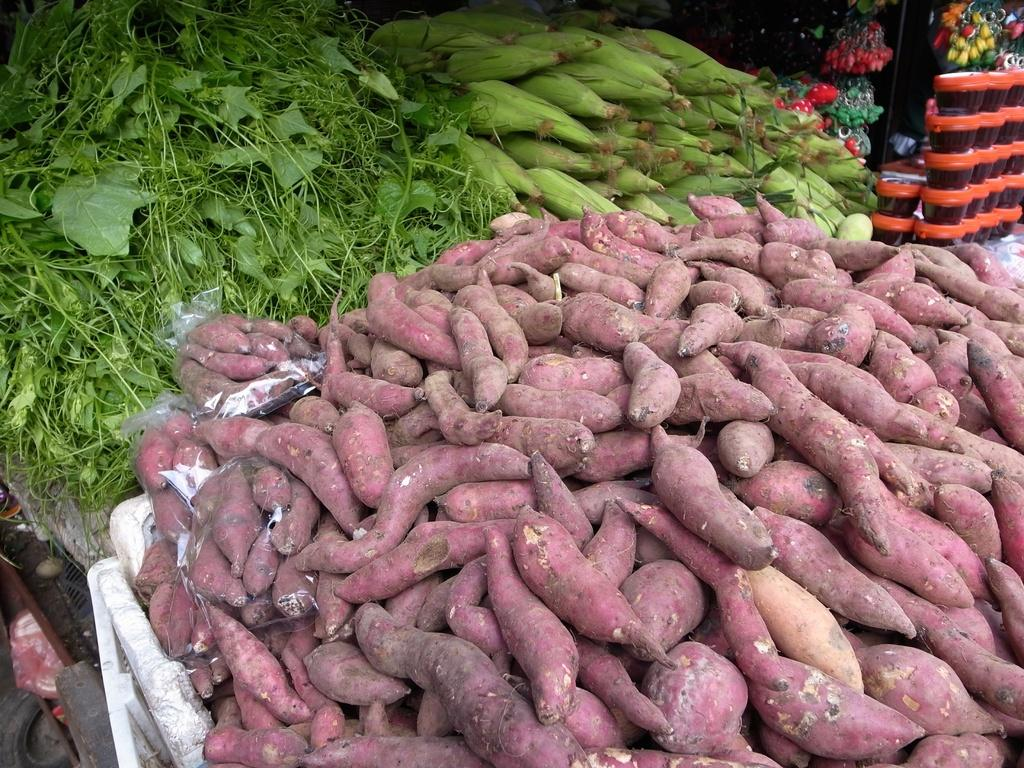What type of vegetables can be seen in the image? There are leafy vegetables in the image. What other types of produce are visible in the image? There are corns and sweet potatoes in the image. Are there any other objects present in the image besides the vegetables? Yes, there are some other objects in the image. How many ants can be seen crawling on the sweet potatoes in the image? There are no ants present in the image; it only features leafy vegetables, corns, sweet potatoes, and some other objects. 